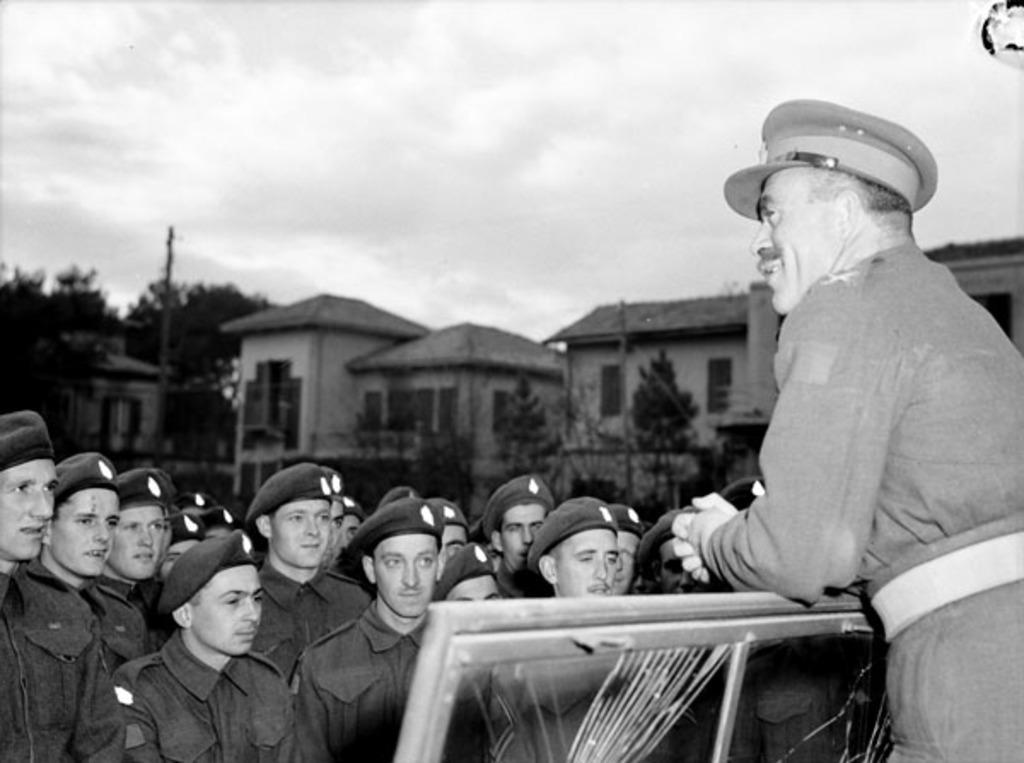Describe this image in one or two sentences. In this image we can see there are people standing on the ground. And there are trees, buildings, pole, wooden object and the sky. 